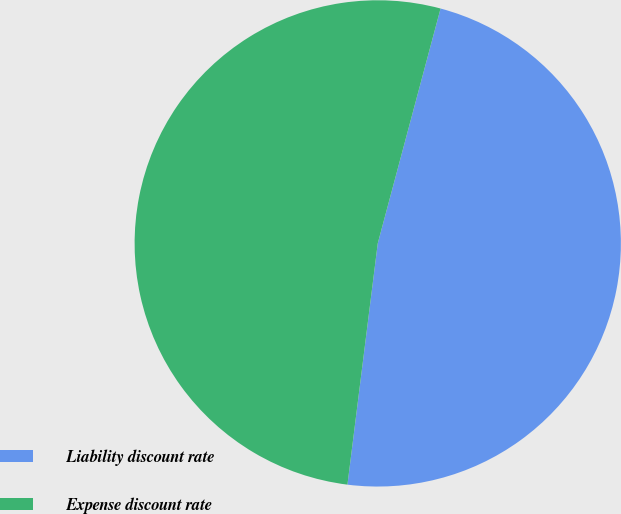Convert chart to OTSL. <chart><loc_0><loc_0><loc_500><loc_500><pie_chart><fcel>Liability discount rate<fcel>Expense discount rate<nl><fcel>47.83%<fcel>52.17%<nl></chart> 